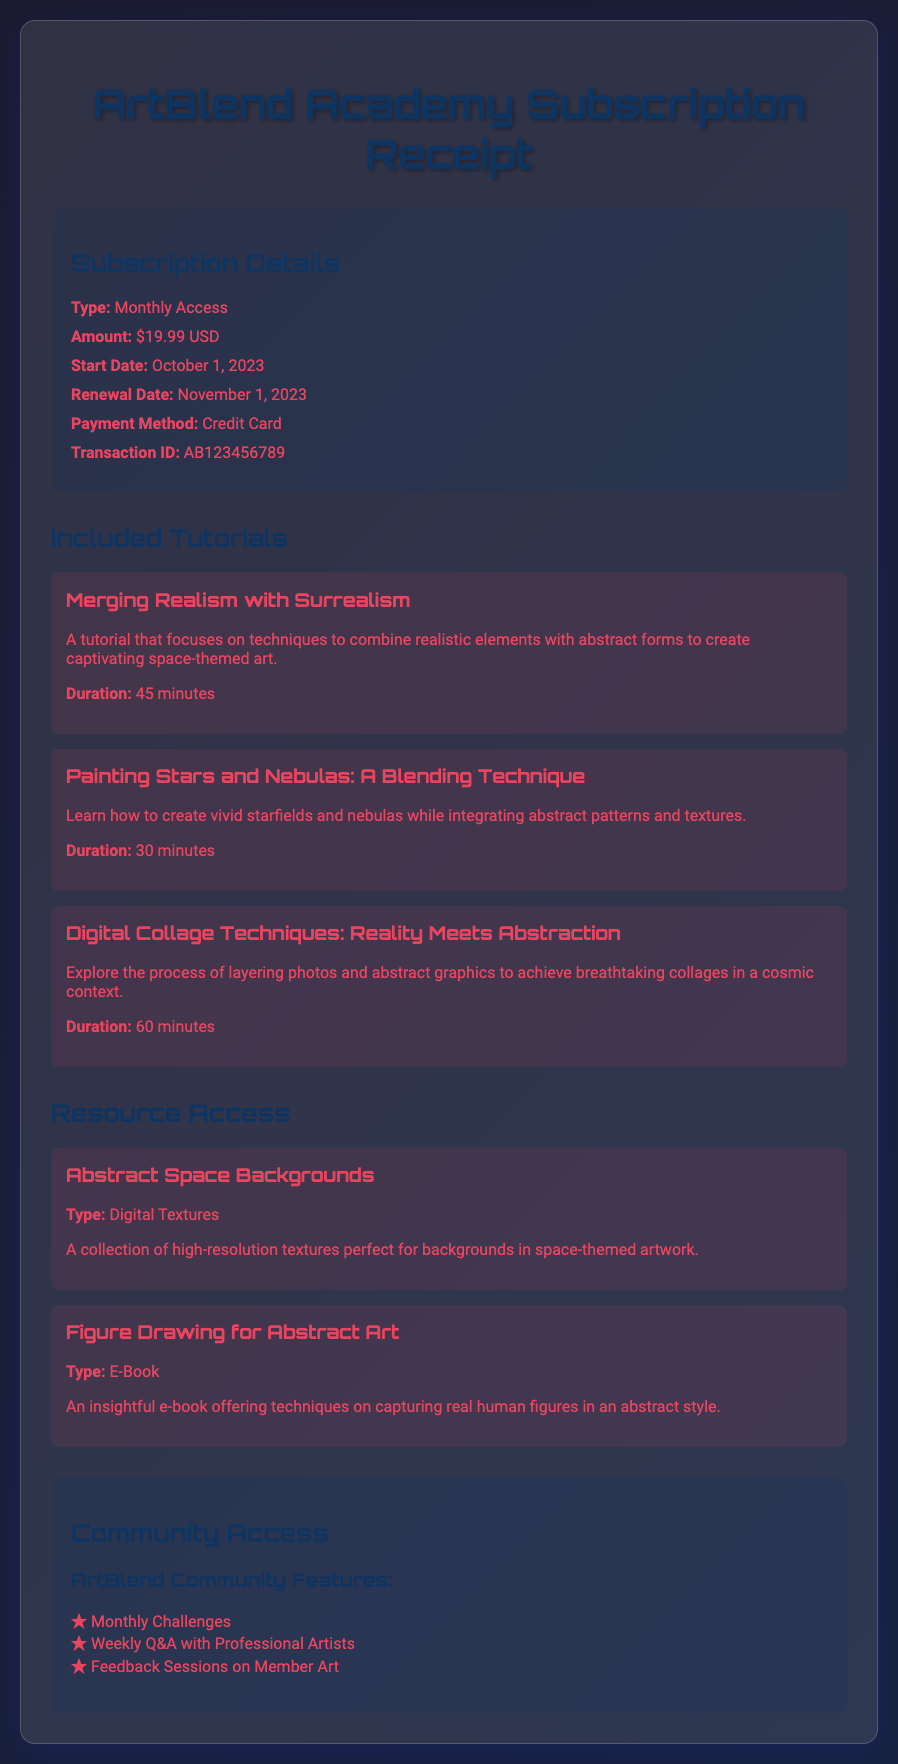What is the subscription type? The subscription type is detailed in the document as "Monthly Access."
Answer: Monthly Access What is the subscription amount? The amount for the subscription is mentioned in the receipt as "$19.99 USD."
Answer: $19.99 USD When does the subscription renewal date occur? The renewal date is provided in the document and is stated as "November 1, 2023."
Answer: November 1, 2023 What is the transaction ID? The transaction ID can be found in the receipt details and is given as "AB123456789."
Answer: AB123456789 What is the duration of the tutorial "Merging Realism with Surrealism"? The duration of this tutorial is specified in the document as "45 minutes."
Answer: 45 minutes How many tutorials are included? The document lists three tutorials, which means there are a total of three included.
Answer: Three What are members able to participate in monthly? The document mentions "Monthly Challenges" as an activity members can participate in.
Answer: Monthly Challenges What kind of resource is “Figure Drawing for Abstract Art”? The document specifies it as an "E-Book."
Answer: E-Book What method of payment was used for the subscription? The payment method is noted in the receipt as "Credit Card."
Answer: Credit Card 